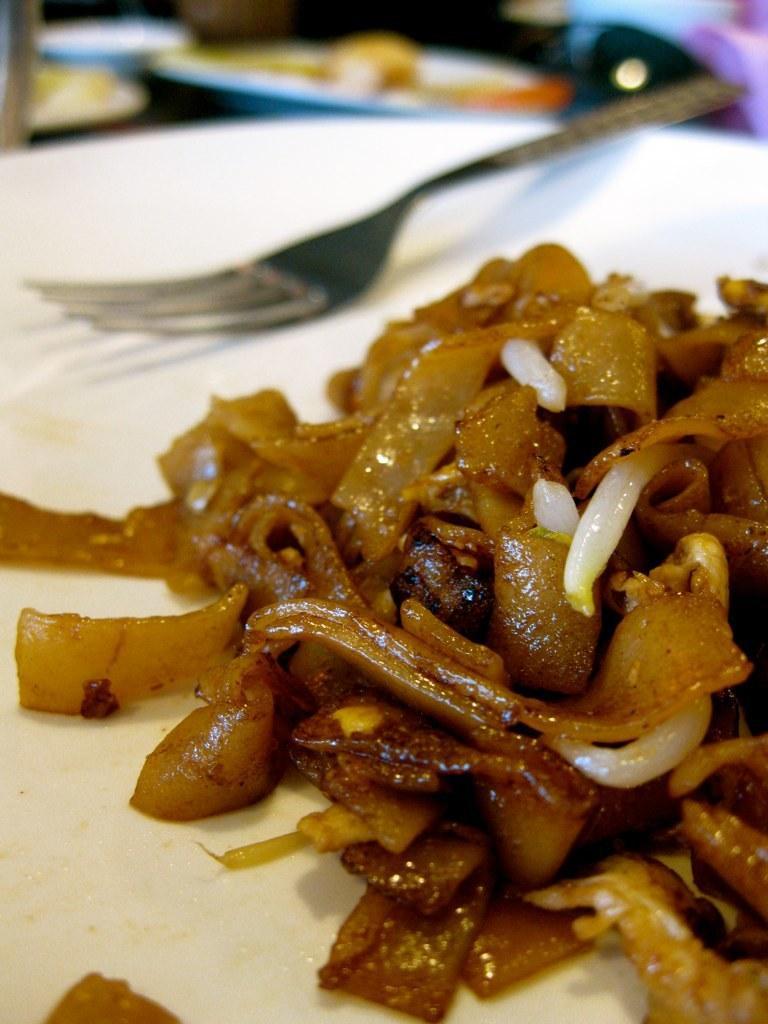How would you summarize this image in a sentence or two? In this image we can see some food items on the plates, there is a fork on a plate, and the background is blurred. 